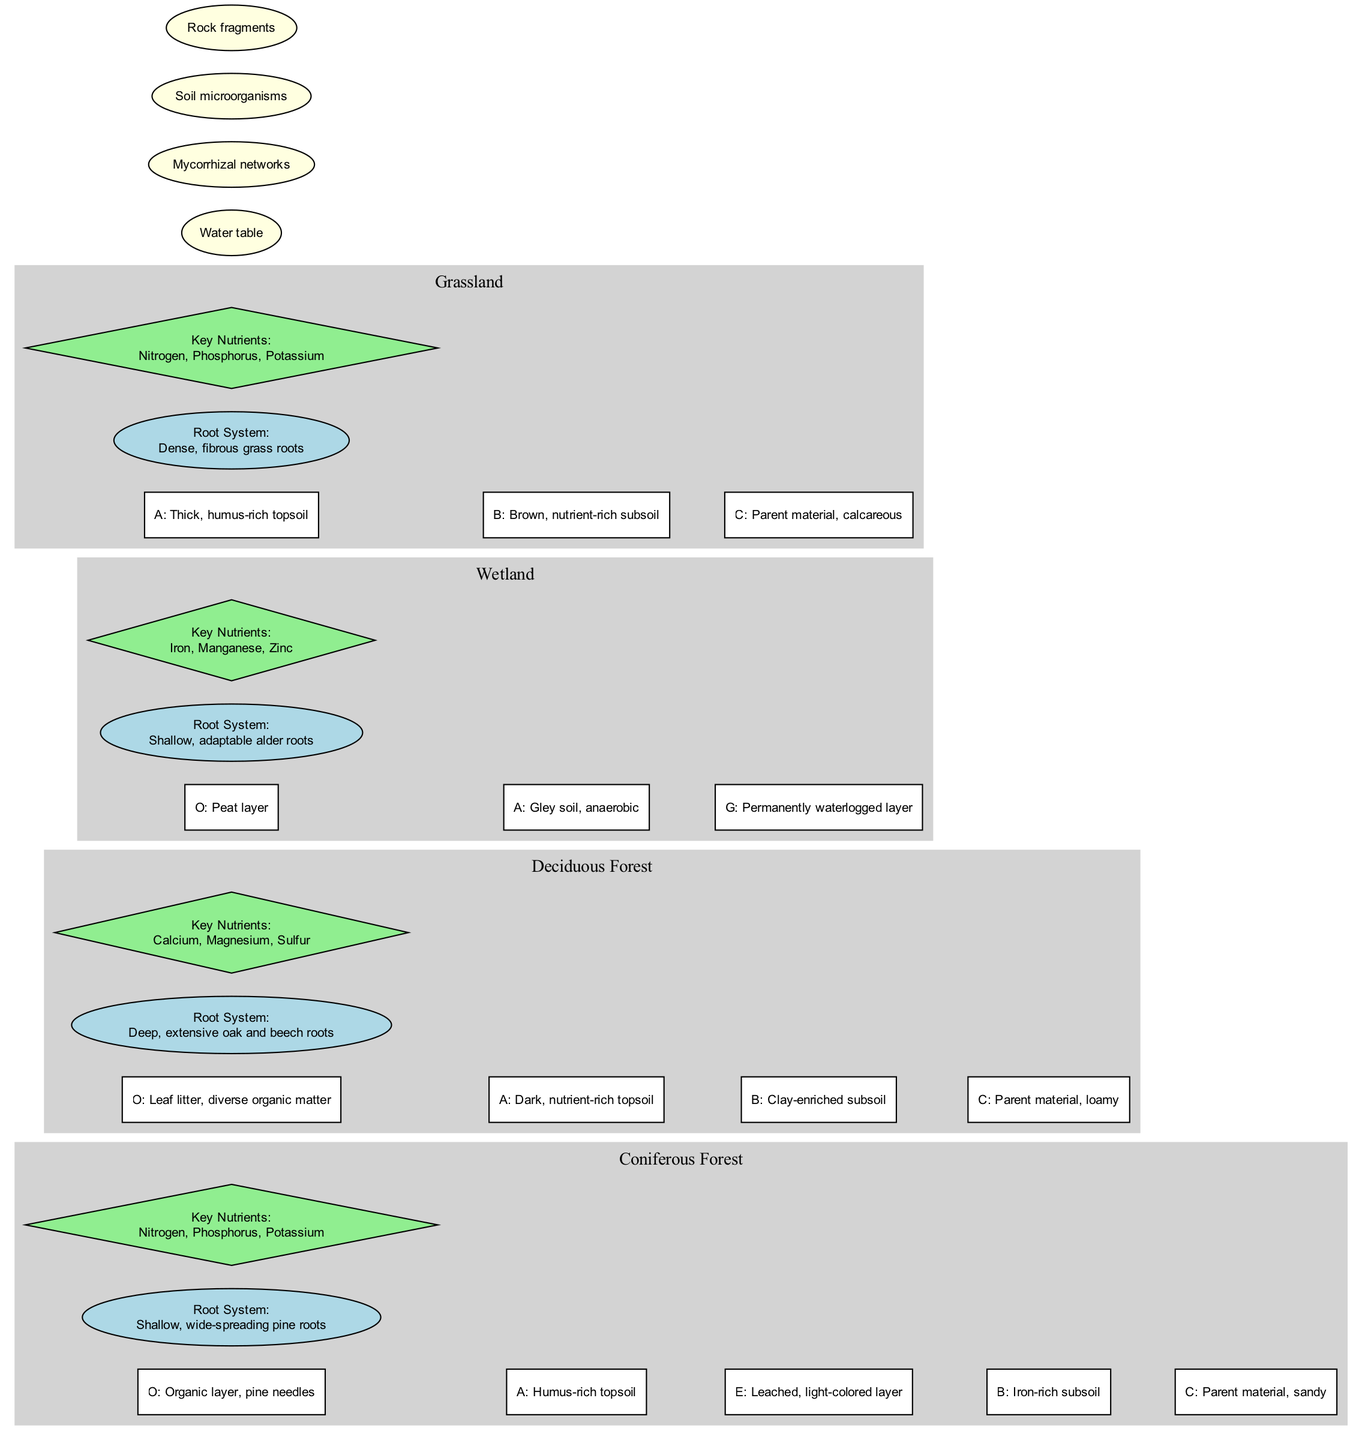What are the key nutrients in the Coniferous Forest habitat? The Coniferous Forest layer lists its key nutrients as Nitrogen, Phosphorus, and Potassium, which can be found within the nodes corresponding to this habitat.
Answer: Nitrogen, Phosphorus, Potassium How many horizons are there in the Deciduous Forest? The Deciduous Forest habitat has four defined horizons: O, A, B, and C. Counting these gives a total of four.
Answer: 4 Which habitat has the deepest root system? The Deciduous Forest is identified by "Deep, extensive oak and beech roots," which suggests it has the deepest root system compared to the other habitats.
Answer: Deciduous Forest What layer is found directly above the iron-rich subsoil in the Coniferous Forest? In the Coniferous Forest, the horizon layout shows that the iron-rich subsoil (B) is directly beneath the leached layer (E), making the E layer directly above B.
Answer: E What is the main characteristic of the Wetland's A horizon? The A horizon in the Wetland is described as "Gley soil, anaerobic," indicating its unique properties.
Answer: Gley soil, anaerobic Which habitat has a thick, humus-rich topsoil? The Grassland habitat features a horizon labeled A that is described as "Thick, humus-rich topsoil," highlighting its richness.
Answer: Grassland What common feature is likely shared across all habitats? The diagram indicates "Soil microorganisms" as a common feature, which implies it is found in all habitats.
Answer: Soil microorganisms Which horizon in the Wetland is characterized as permanently waterlogged? The G horizon in the Wetland is specifically labeled as "Permanently waterlogged layer," indicating its nature.
Answer: Permanently waterlogged layer Which habitat's root system is described as shallow and adaptable? The Wetland's root system is described in the diagram as "Shallow, adaptable alder roots," pointing to its nature distinctively.
Answer: Wetland 